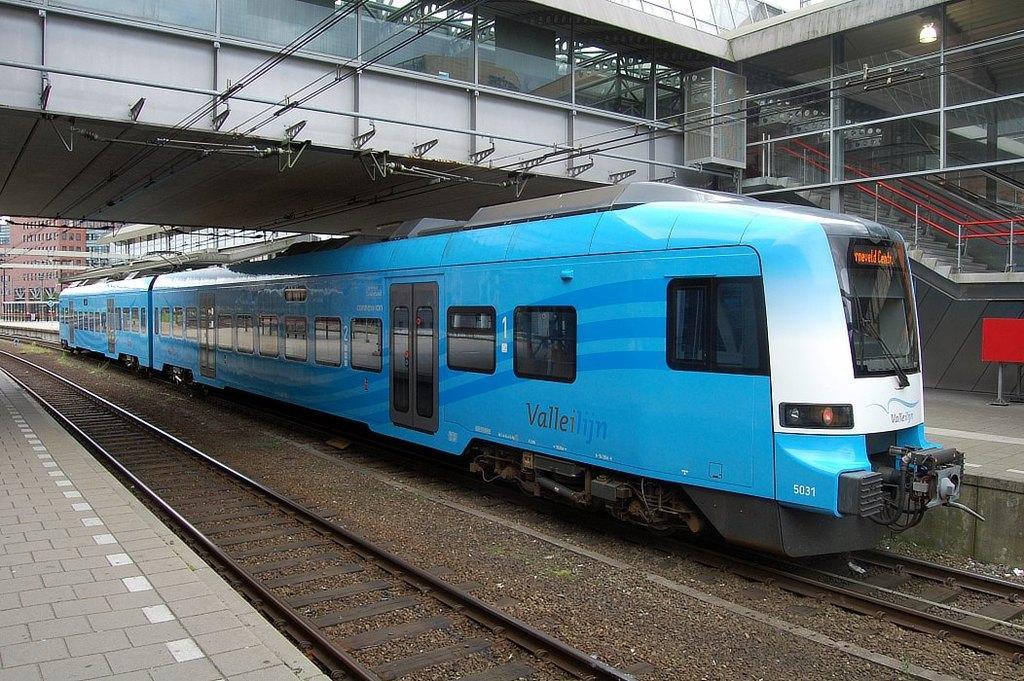Please provide a concise description of this image. In this image I can see a train on the track and the train is in white and blue color, background I can see a bridge and few stairs. I can also see few buildings in white and brown color. 